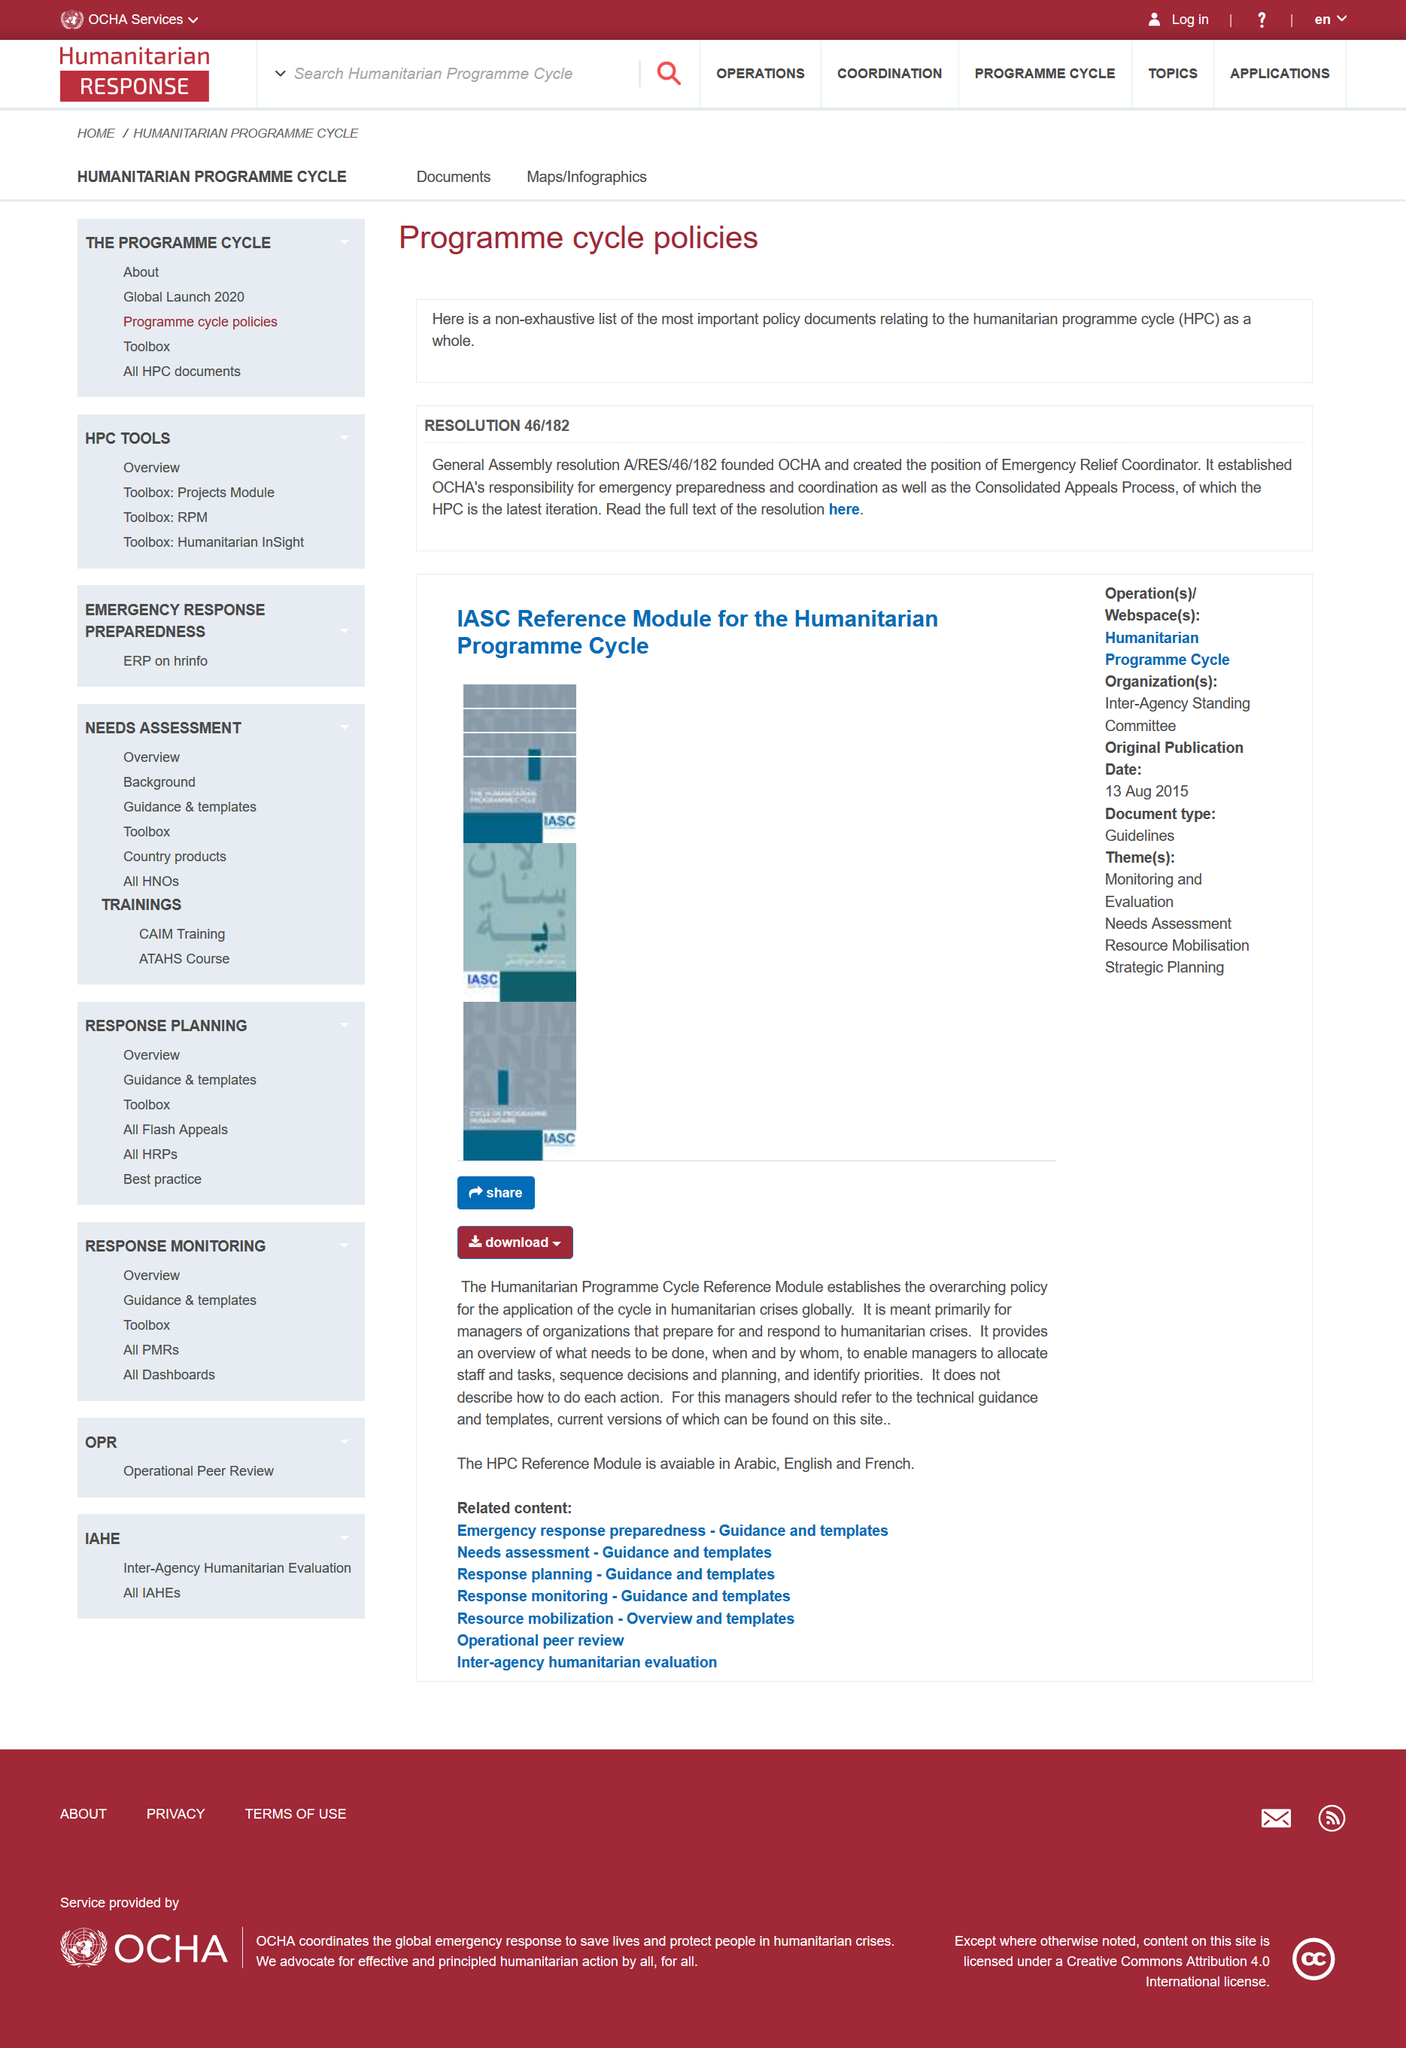Draw attention to some important aspects in this diagram. OCHA was founded by the resolution A/RES/46/182 of the United Nations General Assembly. OCHA created the position of Emergency Relief Coordinator, which is responsible for coordinating humanitarian relief efforts in emergency situations. OCHA is responsible for emergency preparedness and coordination. 